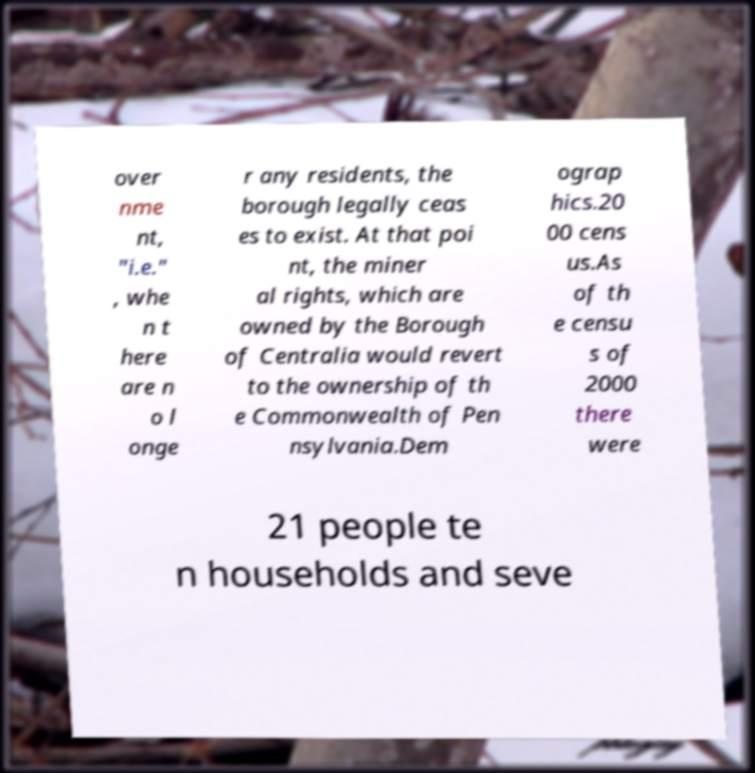What messages or text are displayed in this image? I need them in a readable, typed format. over nme nt, "i.e." , whe n t here are n o l onge r any residents, the borough legally ceas es to exist. At that poi nt, the miner al rights, which are owned by the Borough of Centralia would revert to the ownership of th e Commonwealth of Pen nsylvania.Dem ograp hics.20 00 cens us.As of th e censu s of 2000 there were 21 people te n households and seve 